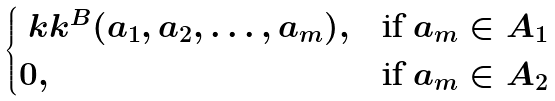<formula> <loc_0><loc_0><loc_500><loc_500>\begin{cases} \ k k ^ { B } ( a _ { 1 } , a _ { 2 } , \dots , a _ { m } ) , & \text {if $a_{m}\in A_{1}$} \\ 0 , & \text {if $a_{m}\in A_{2}$} \end{cases}</formula> 